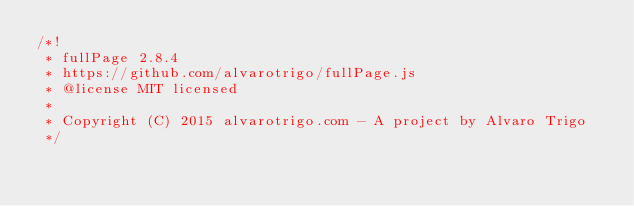Convert code to text. <code><loc_0><loc_0><loc_500><loc_500><_JavaScript_>/*!
 * fullPage 2.8.4
 * https://github.com/alvarotrigo/fullPage.js
 * @license MIT licensed
 *
 * Copyright (C) 2015 alvarotrigo.com - A project by Alvaro Trigo
 */</code> 